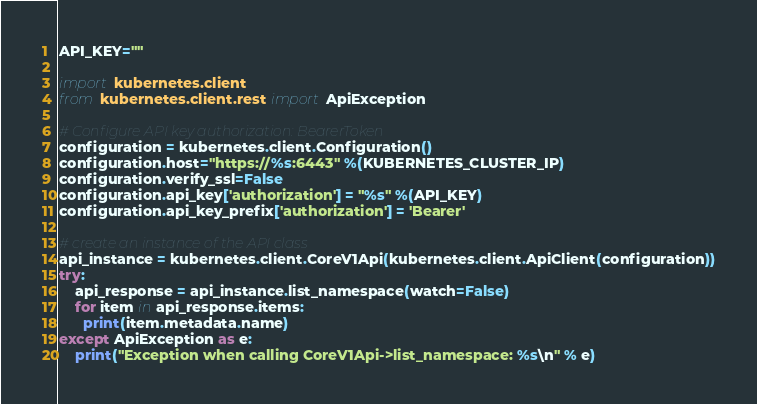<code> <loc_0><loc_0><loc_500><loc_500><_Python_>API_KEY=""

import kubernetes.client
from kubernetes.client.rest import ApiException

# Configure API key authorization: BearerToken
configuration = kubernetes.client.Configuration()
configuration.host="https://%s:6443" %(KUBERNETES_CLUSTER_IP)
configuration.verify_ssl=False
configuration.api_key['authorization'] = "%s" %(API_KEY)
configuration.api_key_prefix['authorization'] = 'Bearer'

# create an instance of the API class
api_instance = kubernetes.client.CoreV1Api(kubernetes.client.ApiClient(configuration))
try:
    api_response = api_instance.list_namespace(watch=False)
    for item in api_response.items:
      print(item.metadata.name)
except ApiException as e:
    print("Exception when calling CoreV1Api->list_namespace: %s\n" % e)
</code> 